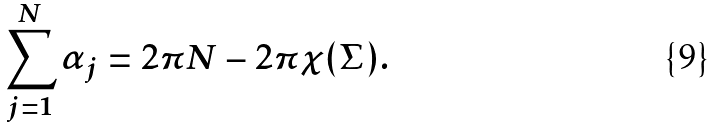Convert formula to latex. <formula><loc_0><loc_0><loc_500><loc_500>\sum _ { j = 1 } ^ { N } \alpha _ { j } = 2 \pi N - 2 \pi \chi ( \Sigma ) .</formula> 